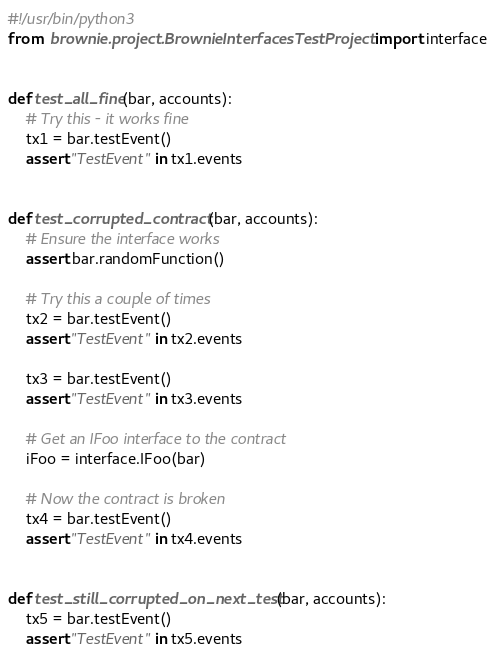<code> <loc_0><loc_0><loc_500><loc_500><_Python_>#!/usr/bin/python3
from  brownie.project.BrownieInterfacesTestProject import interface


def test_all_fine(bar, accounts):
    # Try this - it works fine
    tx1 = bar.testEvent()
    assert "TestEvent" in tx1.events


def test_corrupted_contract(bar, accounts):
    # Ensure the interface works
    assert bar.randomFunction()

    # Try this a couple of times
    tx2 = bar.testEvent()
    assert "TestEvent" in tx2.events

    tx3 = bar.testEvent()
    assert "TestEvent" in tx3.events

    # Get an IFoo interface to the contract
    iFoo = interface.IFoo(bar)

    # Now the contract is broken
    tx4 = bar.testEvent()
    assert "TestEvent" in tx4.events


def test_still_corrupted_on_next_test(bar, accounts):
    tx5 = bar.testEvent()
    assert "TestEvent" in tx5.events
</code> 